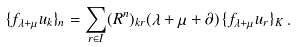Convert formula to latex. <formula><loc_0><loc_0><loc_500><loc_500>\{ f _ { \lambda + \mu } { u _ { k } } \} _ { n } = \sum _ { r \in I } ( R ^ { n } ) _ { k r } ( \lambda + \mu + \partial ) \, \{ f _ { \lambda + \mu } u _ { r } \} _ { K } \, .</formula> 